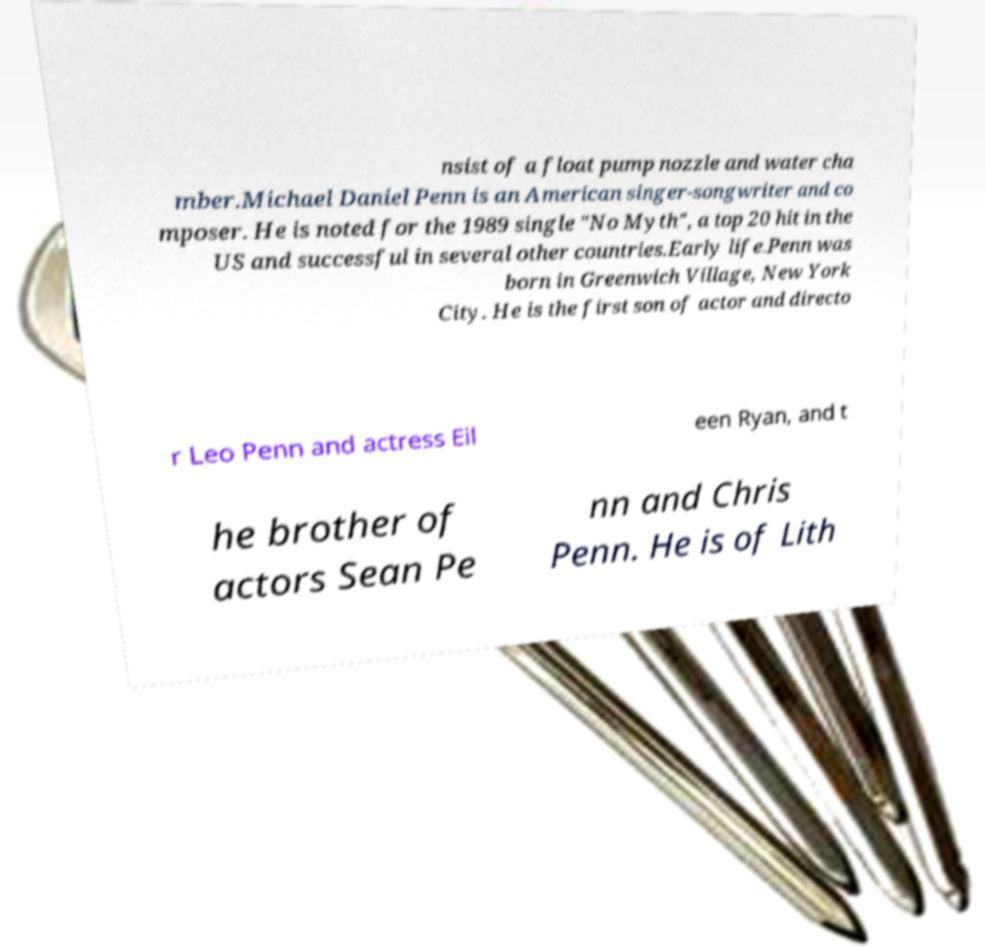Please identify and transcribe the text found in this image. nsist of a float pump nozzle and water cha mber.Michael Daniel Penn is an American singer-songwriter and co mposer. He is noted for the 1989 single "No Myth", a top 20 hit in the US and successful in several other countries.Early life.Penn was born in Greenwich Village, New York City. He is the first son of actor and directo r Leo Penn and actress Eil een Ryan, and t he brother of actors Sean Pe nn and Chris Penn. He is of Lith 